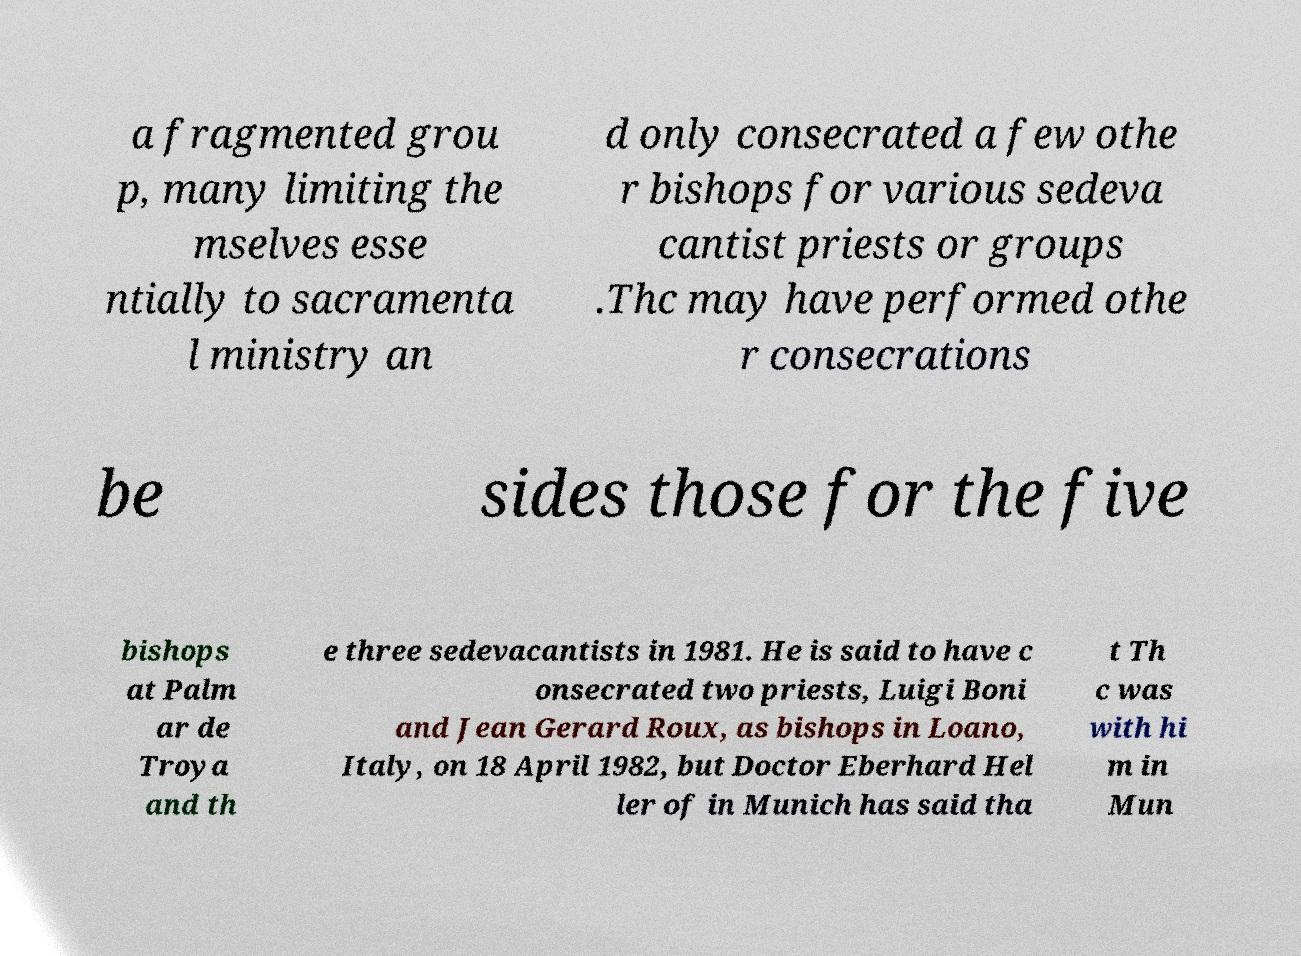Can you read and provide the text displayed in the image?This photo seems to have some interesting text. Can you extract and type it out for me? a fragmented grou p, many limiting the mselves esse ntially to sacramenta l ministry an d only consecrated a few othe r bishops for various sedeva cantist priests or groups .Thc may have performed othe r consecrations be sides those for the five bishops at Palm ar de Troya and th e three sedevacantists in 1981. He is said to have c onsecrated two priests, Luigi Boni and Jean Gerard Roux, as bishops in Loano, Italy, on 18 April 1982, but Doctor Eberhard Hel ler of in Munich has said tha t Th c was with hi m in Mun 